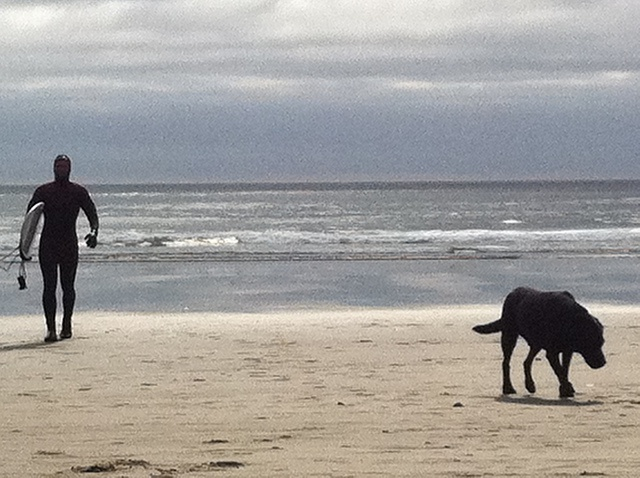Describe the objects in this image and their specific colors. I can see people in lightgray, black, gray, and darkgray tones, dog in lightgray, black, darkgray, and gray tones, and surfboard in lightgray, gray, black, darkgray, and white tones in this image. 